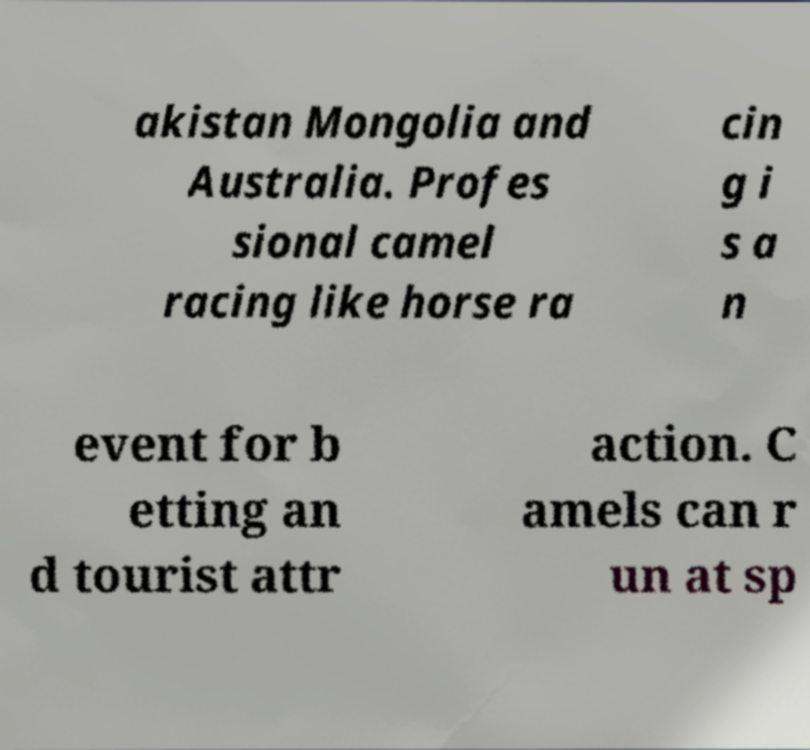Please identify and transcribe the text found in this image. akistan Mongolia and Australia. Profes sional camel racing like horse ra cin g i s a n event for b etting an d tourist attr action. C amels can r un at sp 